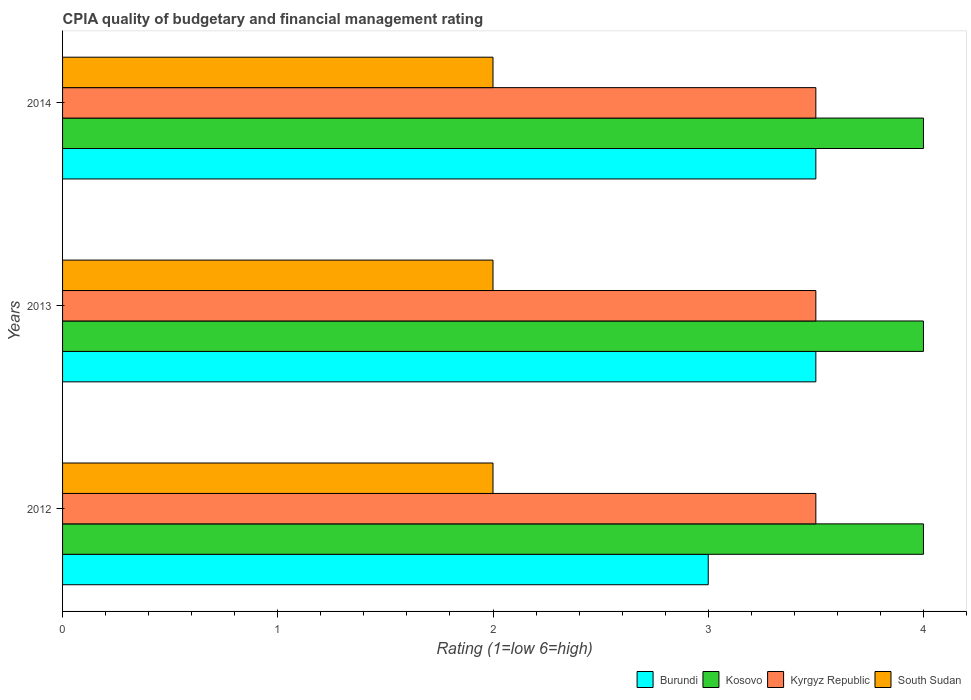How many groups of bars are there?
Provide a short and direct response. 3. Are the number of bars on each tick of the Y-axis equal?
Provide a short and direct response. Yes. How many bars are there on the 1st tick from the top?
Offer a terse response. 4. How many bars are there on the 2nd tick from the bottom?
Your answer should be compact. 4. What is the label of the 3rd group of bars from the top?
Keep it short and to the point. 2012. Across all years, what is the maximum CPIA rating in South Sudan?
Offer a terse response. 2. In which year was the CPIA rating in Kyrgyz Republic maximum?
Keep it short and to the point. 2012. What is the difference between the CPIA rating in Kyrgyz Republic in 2012 and that in 2013?
Your response must be concise. 0. What is the difference between the CPIA rating in Kyrgyz Republic in 2013 and the CPIA rating in Kosovo in 2012?
Your response must be concise. -0.5. What is the average CPIA rating in Burundi per year?
Your response must be concise. 3.33. What is the ratio of the CPIA rating in Burundi in 2012 to that in 2013?
Offer a terse response. 0.86. Is the difference between the CPIA rating in Burundi in 2012 and 2014 greater than the difference between the CPIA rating in Kosovo in 2012 and 2014?
Your answer should be compact. No. What is the difference between the highest and the lowest CPIA rating in Kosovo?
Keep it short and to the point. 0. In how many years, is the CPIA rating in Kyrgyz Republic greater than the average CPIA rating in Kyrgyz Republic taken over all years?
Provide a succinct answer. 0. Is the sum of the CPIA rating in South Sudan in 2013 and 2014 greater than the maximum CPIA rating in Kyrgyz Republic across all years?
Keep it short and to the point. Yes. Is it the case that in every year, the sum of the CPIA rating in Kyrgyz Republic and CPIA rating in Kosovo is greater than the sum of CPIA rating in South Sudan and CPIA rating in Burundi?
Provide a short and direct response. No. What does the 1st bar from the top in 2014 represents?
Offer a terse response. South Sudan. What does the 3rd bar from the bottom in 2014 represents?
Give a very brief answer. Kyrgyz Republic. How many bars are there?
Offer a terse response. 12. Are the values on the major ticks of X-axis written in scientific E-notation?
Provide a short and direct response. No. Does the graph contain grids?
Ensure brevity in your answer.  No. Where does the legend appear in the graph?
Offer a very short reply. Bottom right. How are the legend labels stacked?
Your response must be concise. Horizontal. What is the title of the graph?
Provide a short and direct response. CPIA quality of budgetary and financial management rating. What is the label or title of the Y-axis?
Your answer should be very brief. Years. What is the Rating (1=low 6=high) of Burundi in 2012?
Your response must be concise. 3. What is the Rating (1=low 6=high) in Kosovo in 2012?
Your answer should be compact. 4. What is the Rating (1=low 6=high) of South Sudan in 2012?
Give a very brief answer. 2. What is the Rating (1=low 6=high) in Kosovo in 2013?
Provide a succinct answer. 4. What is the Rating (1=low 6=high) of Kosovo in 2014?
Keep it short and to the point. 4. What is the Rating (1=low 6=high) in South Sudan in 2014?
Your answer should be compact. 2. Across all years, what is the maximum Rating (1=low 6=high) of Burundi?
Offer a very short reply. 3.5. Across all years, what is the maximum Rating (1=low 6=high) of Kosovo?
Your answer should be very brief. 4. Across all years, what is the maximum Rating (1=low 6=high) of Kyrgyz Republic?
Give a very brief answer. 3.5. Across all years, what is the maximum Rating (1=low 6=high) in South Sudan?
Provide a short and direct response. 2. Across all years, what is the minimum Rating (1=low 6=high) of Burundi?
Your answer should be compact. 3. Across all years, what is the minimum Rating (1=low 6=high) of Kyrgyz Republic?
Provide a short and direct response. 3.5. Across all years, what is the minimum Rating (1=low 6=high) in South Sudan?
Offer a very short reply. 2. What is the total Rating (1=low 6=high) of Burundi in the graph?
Provide a succinct answer. 10. What is the total Rating (1=low 6=high) of Kosovo in the graph?
Your answer should be compact. 12. What is the total Rating (1=low 6=high) in Kyrgyz Republic in the graph?
Keep it short and to the point. 10.5. What is the total Rating (1=low 6=high) in South Sudan in the graph?
Offer a very short reply. 6. What is the difference between the Rating (1=low 6=high) of Burundi in 2012 and that in 2013?
Provide a short and direct response. -0.5. What is the difference between the Rating (1=low 6=high) in Kyrgyz Republic in 2012 and that in 2013?
Give a very brief answer. 0. What is the difference between the Rating (1=low 6=high) of South Sudan in 2012 and that in 2013?
Ensure brevity in your answer.  0. What is the difference between the Rating (1=low 6=high) of Kosovo in 2012 and that in 2014?
Give a very brief answer. 0. What is the difference between the Rating (1=low 6=high) of Kyrgyz Republic in 2012 and that in 2014?
Your response must be concise. 0. What is the difference between the Rating (1=low 6=high) of Burundi in 2013 and that in 2014?
Keep it short and to the point. 0. What is the difference between the Rating (1=low 6=high) in Kyrgyz Republic in 2013 and that in 2014?
Give a very brief answer. 0. What is the difference between the Rating (1=low 6=high) in Burundi in 2012 and the Rating (1=low 6=high) in Kyrgyz Republic in 2013?
Your answer should be compact. -0.5. What is the difference between the Rating (1=low 6=high) of Kosovo in 2012 and the Rating (1=low 6=high) of South Sudan in 2013?
Provide a succinct answer. 2. What is the difference between the Rating (1=low 6=high) of Burundi in 2012 and the Rating (1=low 6=high) of Kosovo in 2014?
Provide a succinct answer. -1. What is the difference between the Rating (1=low 6=high) in Burundi in 2012 and the Rating (1=low 6=high) in Kyrgyz Republic in 2014?
Offer a terse response. -0.5. What is the difference between the Rating (1=low 6=high) of Kosovo in 2012 and the Rating (1=low 6=high) of Kyrgyz Republic in 2014?
Make the answer very short. 0.5. What is the difference between the Rating (1=low 6=high) in Kosovo in 2012 and the Rating (1=low 6=high) in South Sudan in 2014?
Make the answer very short. 2. What is the difference between the Rating (1=low 6=high) in Kyrgyz Republic in 2012 and the Rating (1=low 6=high) in South Sudan in 2014?
Ensure brevity in your answer.  1.5. What is the difference between the Rating (1=low 6=high) in Burundi in 2013 and the Rating (1=low 6=high) in Kosovo in 2014?
Provide a succinct answer. -0.5. What is the difference between the Rating (1=low 6=high) in Kosovo in 2013 and the Rating (1=low 6=high) in Kyrgyz Republic in 2014?
Your answer should be very brief. 0.5. What is the average Rating (1=low 6=high) of Burundi per year?
Offer a terse response. 3.33. What is the average Rating (1=low 6=high) of Kosovo per year?
Your response must be concise. 4. What is the average Rating (1=low 6=high) of Kyrgyz Republic per year?
Offer a terse response. 3.5. What is the average Rating (1=low 6=high) in South Sudan per year?
Provide a succinct answer. 2. In the year 2012, what is the difference between the Rating (1=low 6=high) of Burundi and Rating (1=low 6=high) of South Sudan?
Make the answer very short. 1. In the year 2012, what is the difference between the Rating (1=low 6=high) in Kosovo and Rating (1=low 6=high) in Kyrgyz Republic?
Provide a short and direct response. 0.5. In the year 2012, what is the difference between the Rating (1=low 6=high) of Kyrgyz Republic and Rating (1=low 6=high) of South Sudan?
Provide a short and direct response. 1.5. In the year 2013, what is the difference between the Rating (1=low 6=high) of Burundi and Rating (1=low 6=high) of South Sudan?
Provide a succinct answer. 1.5. In the year 2013, what is the difference between the Rating (1=low 6=high) of Kosovo and Rating (1=low 6=high) of Kyrgyz Republic?
Ensure brevity in your answer.  0.5. In the year 2013, what is the difference between the Rating (1=low 6=high) in Kosovo and Rating (1=low 6=high) in South Sudan?
Your response must be concise. 2. In the year 2013, what is the difference between the Rating (1=low 6=high) of Kyrgyz Republic and Rating (1=low 6=high) of South Sudan?
Give a very brief answer. 1.5. In the year 2014, what is the difference between the Rating (1=low 6=high) of Burundi and Rating (1=low 6=high) of Kosovo?
Offer a very short reply. -0.5. In the year 2014, what is the difference between the Rating (1=low 6=high) in Burundi and Rating (1=low 6=high) in Kyrgyz Republic?
Your answer should be very brief. 0. In the year 2014, what is the difference between the Rating (1=low 6=high) in Kosovo and Rating (1=low 6=high) in Kyrgyz Republic?
Offer a very short reply. 0.5. In the year 2014, what is the difference between the Rating (1=low 6=high) of Kosovo and Rating (1=low 6=high) of South Sudan?
Your answer should be very brief. 2. In the year 2014, what is the difference between the Rating (1=low 6=high) of Kyrgyz Republic and Rating (1=low 6=high) of South Sudan?
Give a very brief answer. 1.5. What is the ratio of the Rating (1=low 6=high) in Burundi in 2012 to that in 2013?
Your answer should be very brief. 0.86. What is the ratio of the Rating (1=low 6=high) in Kosovo in 2012 to that in 2013?
Provide a short and direct response. 1. What is the ratio of the Rating (1=low 6=high) in South Sudan in 2012 to that in 2013?
Give a very brief answer. 1. What is the ratio of the Rating (1=low 6=high) in Burundi in 2012 to that in 2014?
Ensure brevity in your answer.  0.86. What is the ratio of the Rating (1=low 6=high) of Kosovo in 2012 to that in 2014?
Provide a short and direct response. 1. What is the ratio of the Rating (1=low 6=high) in Burundi in 2013 to that in 2014?
Provide a short and direct response. 1. What is the ratio of the Rating (1=low 6=high) in South Sudan in 2013 to that in 2014?
Make the answer very short. 1. What is the difference between the highest and the second highest Rating (1=low 6=high) in Burundi?
Provide a succinct answer. 0. What is the difference between the highest and the second highest Rating (1=low 6=high) of Kyrgyz Republic?
Make the answer very short. 0. What is the difference between the highest and the lowest Rating (1=low 6=high) of Burundi?
Give a very brief answer. 0.5. What is the difference between the highest and the lowest Rating (1=low 6=high) in Kosovo?
Give a very brief answer. 0. 